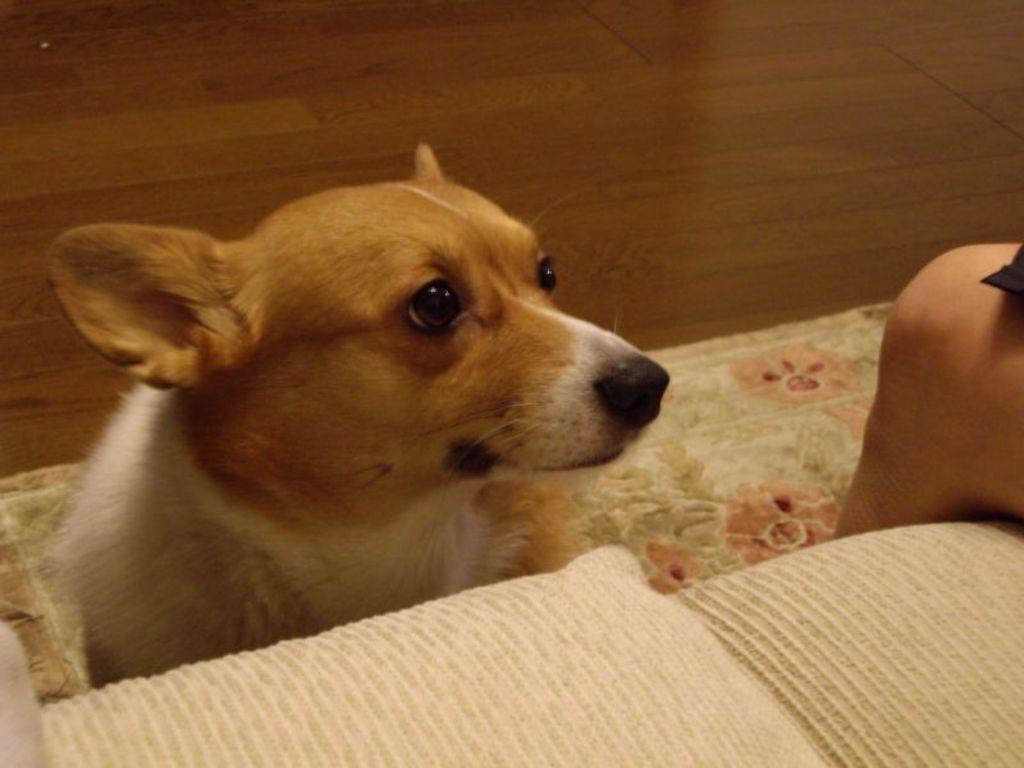How would you summarize this image in a sentence or two? In the center of the image there is a dog. In the bottom of the image there is a sofa. In the background of the image there is a wooden flooring. To the right side of the image there is a person's leg. 